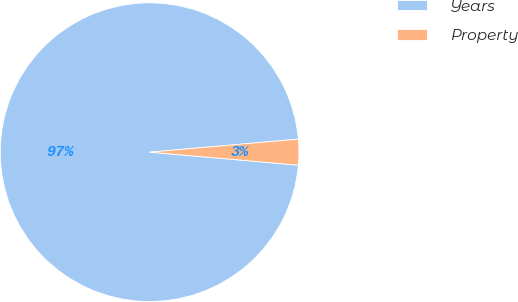Convert chart to OTSL. <chart><loc_0><loc_0><loc_500><loc_500><pie_chart><fcel>Years<fcel>Property<nl><fcel>97.22%<fcel>2.78%<nl></chart> 